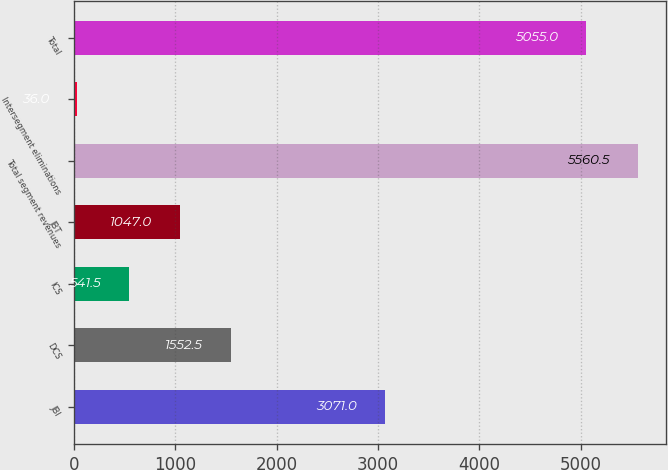<chart> <loc_0><loc_0><loc_500><loc_500><bar_chart><fcel>JBI<fcel>DCS<fcel>ICS<fcel>JBT<fcel>Total segment revenues<fcel>Intersegment eliminations<fcel>Total<nl><fcel>3071<fcel>1552.5<fcel>541.5<fcel>1047<fcel>5560.5<fcel>36<fcel>5055<nl></chart> 